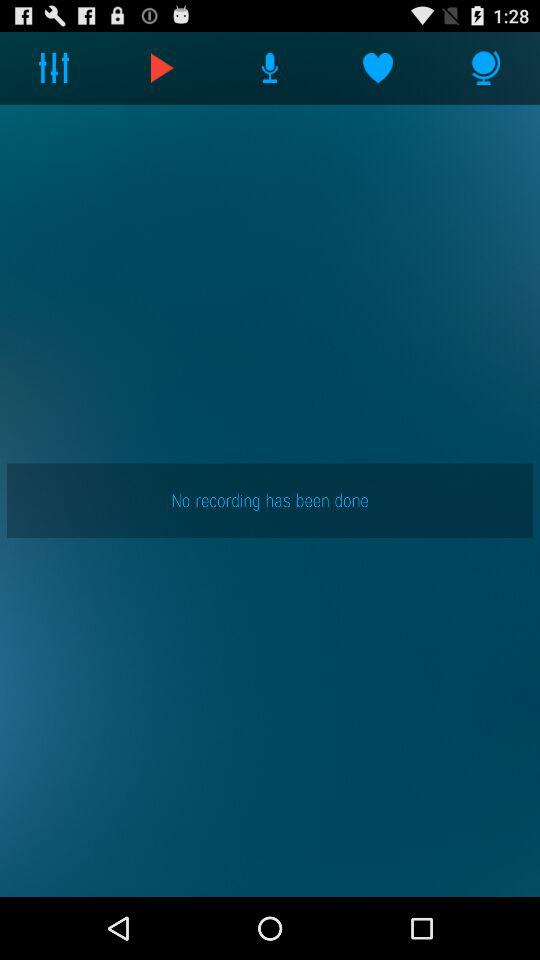Which tab has been selected? The tab that has been selected is "Recordings". 